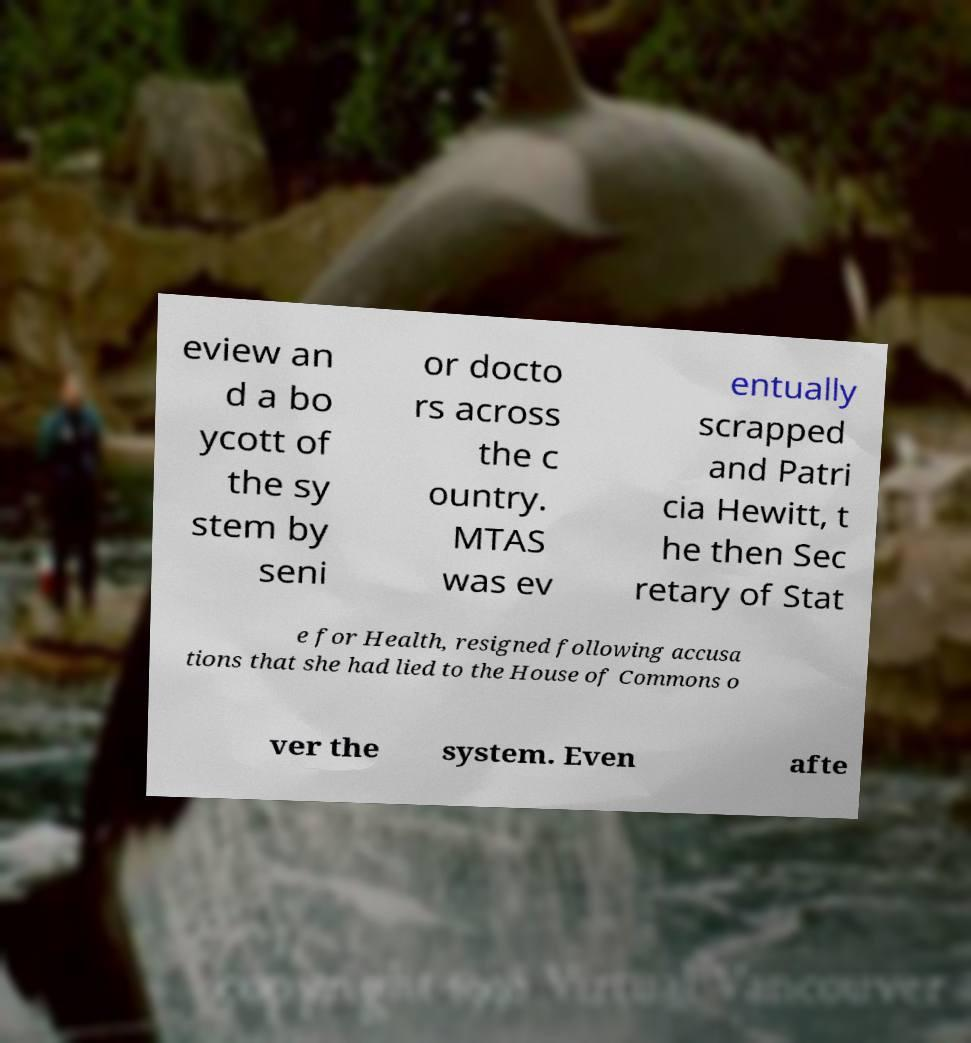I need the written content from this picture converted into text. Can you do that? eview an d a bo ycott of the sy stem by seni or docto rs across the c ountry. MTAS was ev entually scrapped and Patri cia Hewitt, t he then Sec retary of Stat e for Health, resigned following accusa tions that she had lied to the House of Commons o ver the system. Even afte 